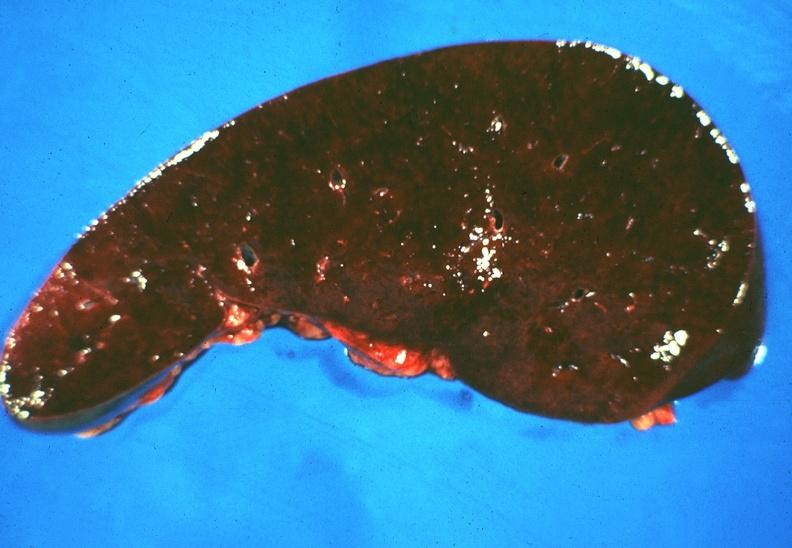does marked show spleen, hemochromatosis?
Answer the question using a single word or phrase. No 